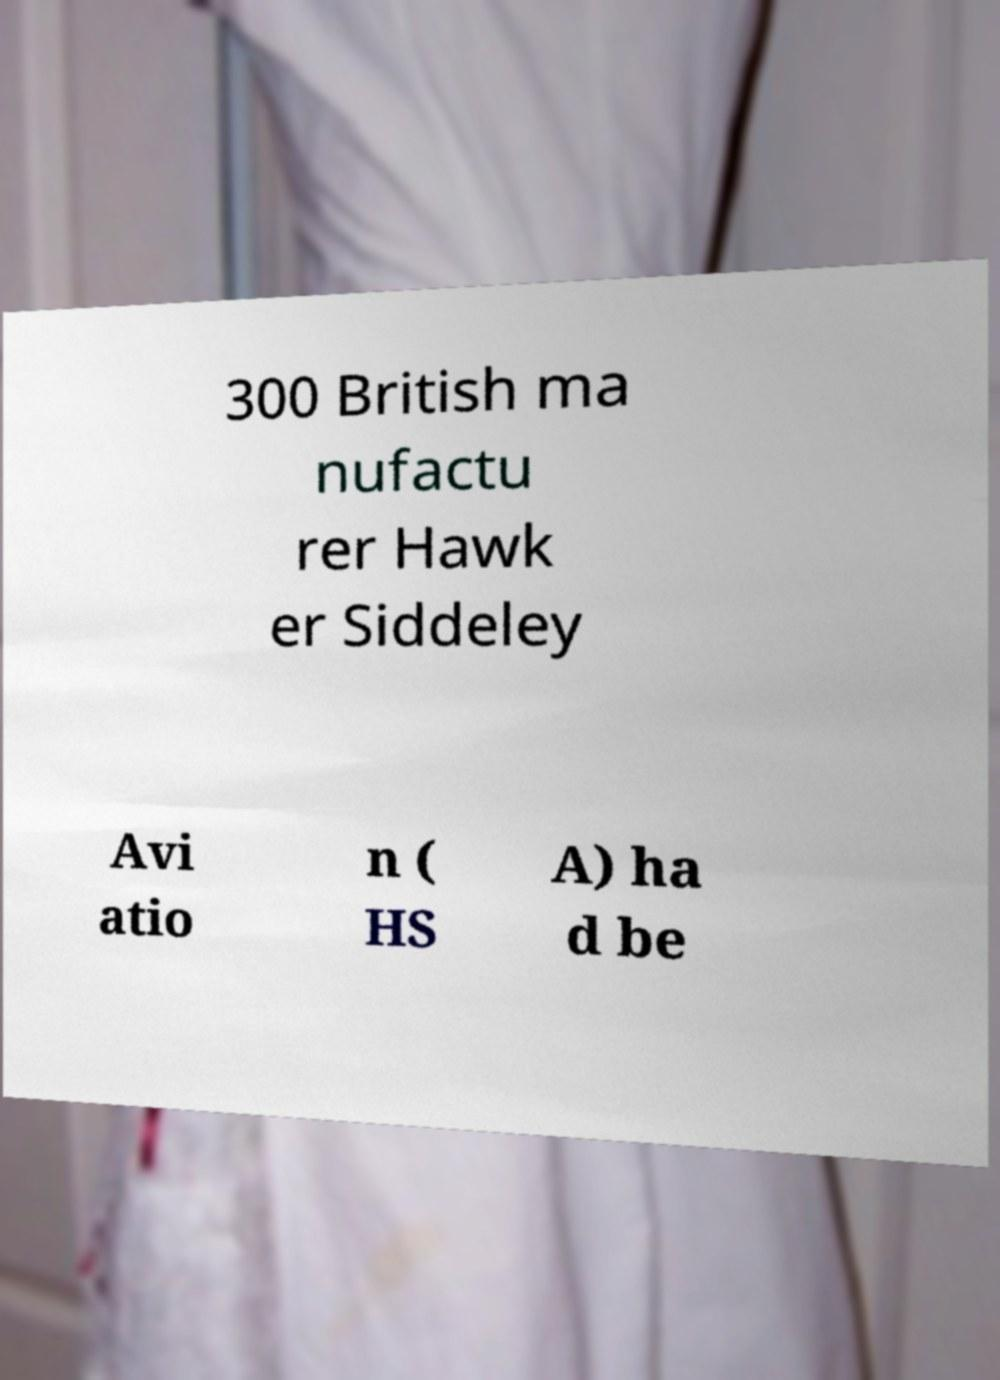Could you assist in decoding the text presented in this image and type it out clearly? 300 British ma nufactu rer Hawk er Siddeley Avi atio n ( HS A) ha d be 